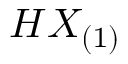Convert formula to latex. <formula><loc_0><loc_0><loc_500><loc_500>H X _ { ( 1 ) }</formula> 